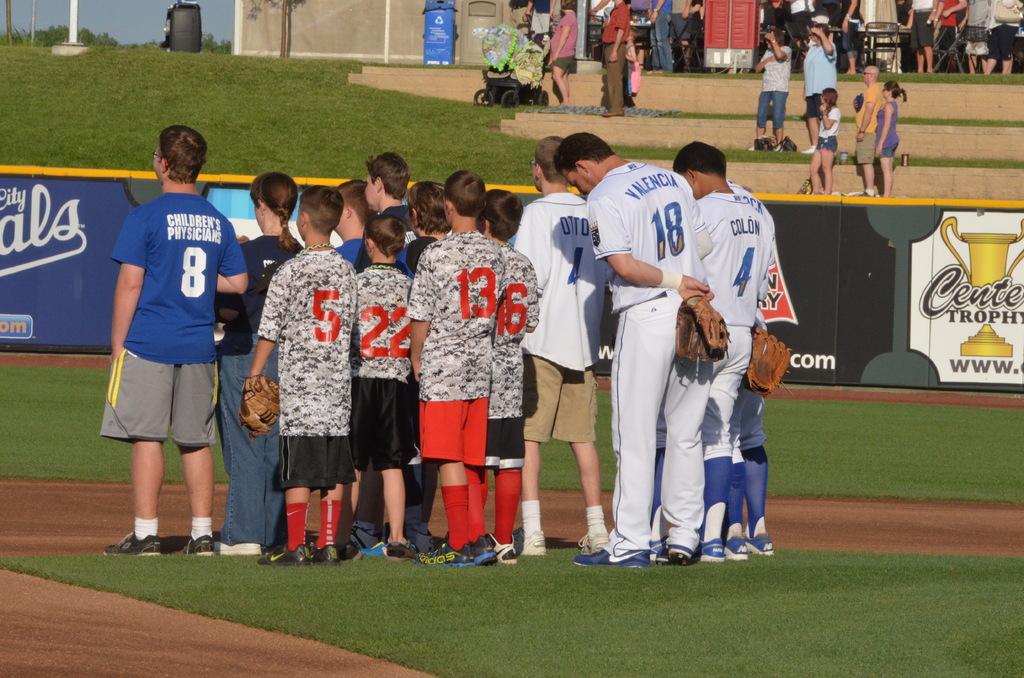What number is on the left-most blue person's shirt?
Offer a very short reply. 8. Is the word children's physicare above the letter 8 on the blue shirt?
Offer a terse response. Yes. 